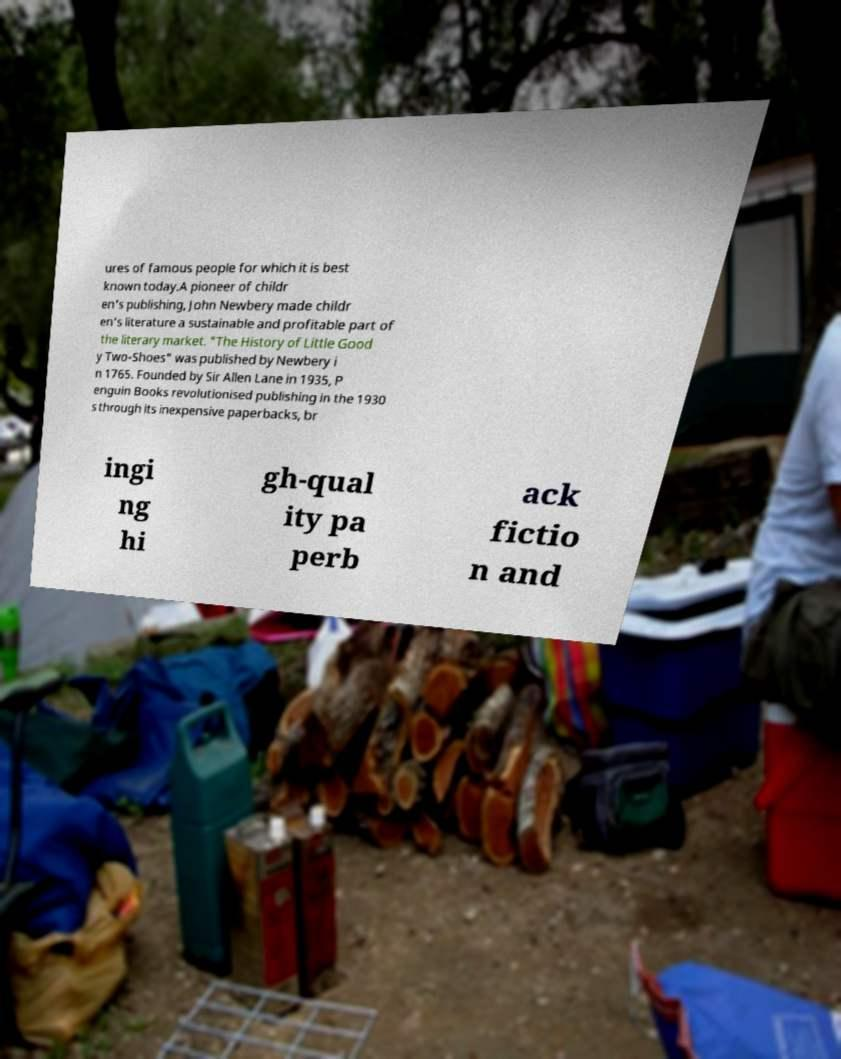Could you assist in decoding the text presented in this image and type it out clearly? ures of famous people for which it is best known today.A pioneer of childr en's publishing, John Newbery made childr en's literature a sustainable and profitable part of the literary market. "The History of Little Good y Two-Shoes" was published by Newbery i n 1765. Founded by Sir Allen Lane in 1935, P enguin Books revolutionised publishing in the 1930 s through its inexpensive paperbacks, br ingi ng hi gh-qual ity pa perb ack fictio n and 